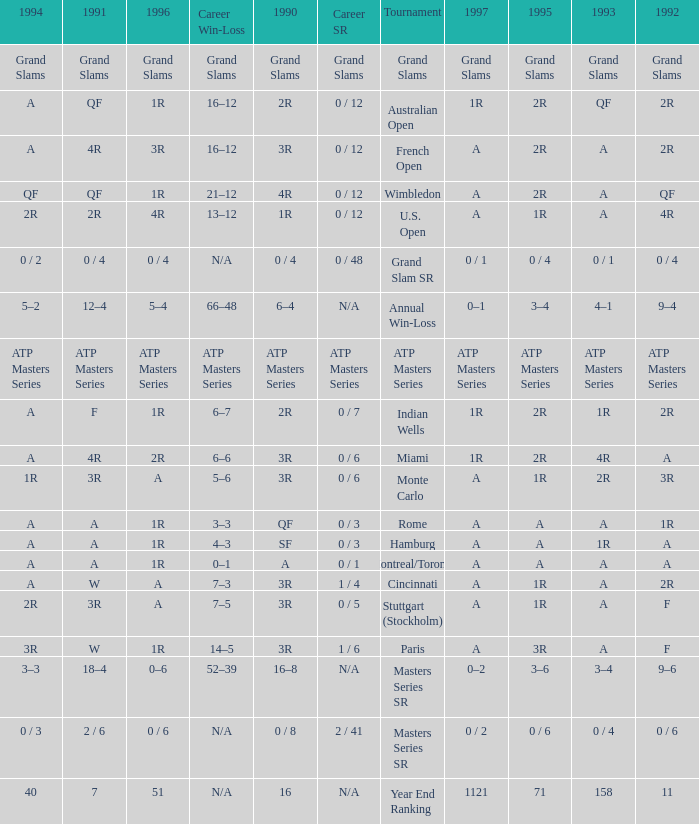What is 1995, when Tournament is "Miami"? 2R. 